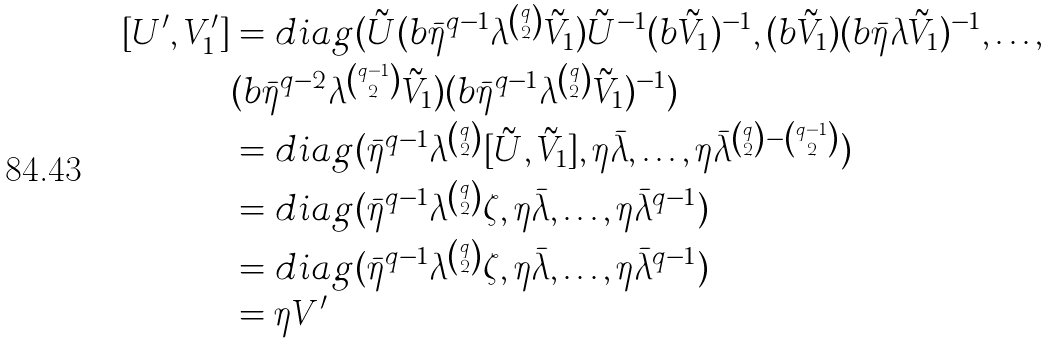Convert formula to latex. <formula><loc_0><loc_0><loc_500><loc_500>[ U ^ { \prime } , V ^ { \prime } _ { 1 } ] & = d i a g ( \tilde { U } ( b \bar { \eta } ^ { q - 1 } \lambda ^ { \binom { q } { 2 } } \tilde { V } _ { 1 } ) \tilde { U } ^ { - 1 } ( b \tilde { V } _ { 1 } ) ^ { - 1 } , ( b \tilde { V } _ { 1 } ) ( b \bar { \eta } \lambda \tilde { V } _ { 1 } ) ^ { - 1 } , \dots , \\ & ( b \bar { \eta } ^ { q - 2 } \lambda ^ { \binom { q - 1 } { 2 } } \tilde { V } _ { 1 } ) ( b \bar { \eta } ^ { q - 1 } \lambda ^ { \binom { q } { 2 } } \tilde { V } _ { 1 } ) ^ { - 1 } ) \\ & = d i a g ( \bar { \eta } ^ { q - 1 } \lambda ^ { \binom { q } { 2 } } [ \tilde { U } , \tilde { V } _ { 1 } ] , \eta \bar { \lambda } , \dots , \eta \bar { \lambda } ^ { \binom { q } { 2 } - \binom { q - 1 } { 2 } } ) \\ & = d i a g ( \bar { \eta } ^ { q - 1 } \lambda ^ { \binom { q } { 2 } } \zeta , \eta \bar { \lambda } , \dots , \eta \bar { \lambda } ^ { q - 1 } ) \\ & = d i a g ( \bar { \eta } ^ { q - 1 } \lambda ^ { \binom { q } { 2 } } \zeta , \eta \bar { \lambda } , \dots , \eta \bar { \lambda } ^ { q - 1 } ) \\ & = \eta V ^ { \prime }</formula> 